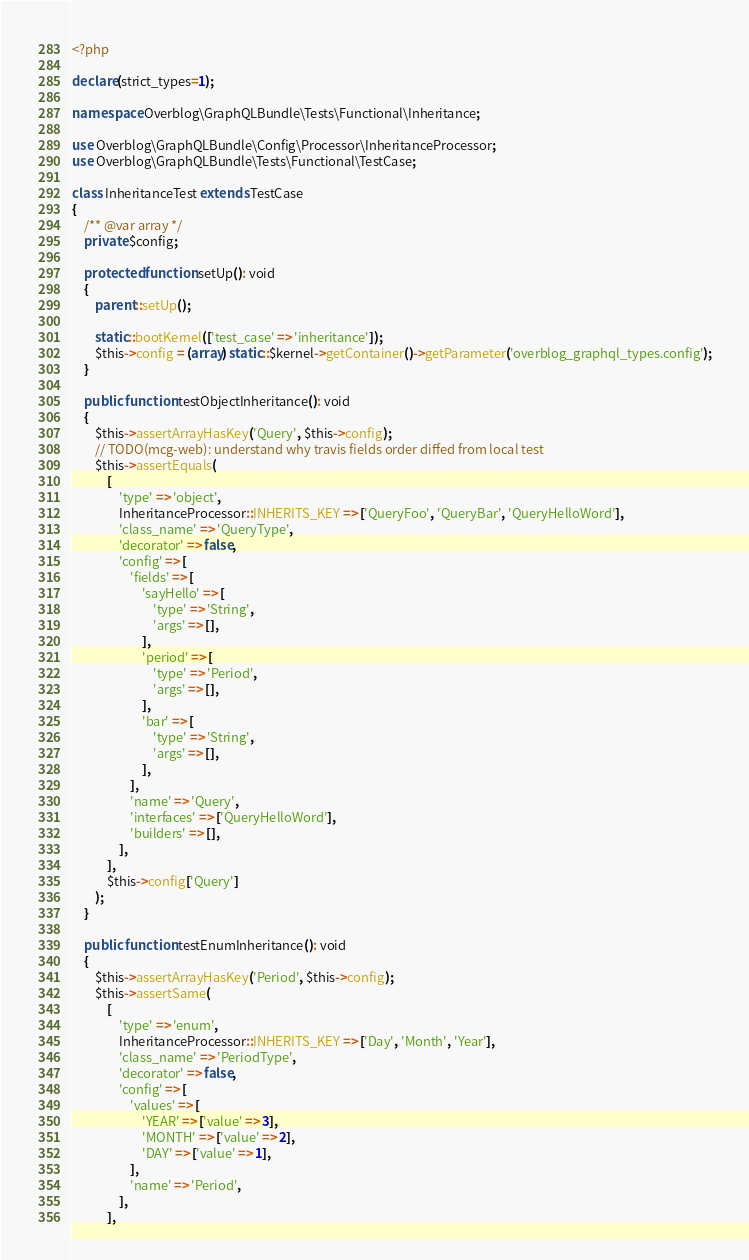Convert code to text. <code><loc_0><loc_0><loc_500><loc_500><_PHP_><?php

declare(strict_types=1);

namespace Overblog\GraphQLBundle\Tests\Functional\Inheritance;

use Overblog\GraphQLBundle\Config\Processor\InheritanceProcessor;
use Overblog\GraphQLBundle\Tests\Functional\TestCase;

class InheritanceTest extends TestCase
{
    /** @var array */
    private $config;

    protected function setUp(): void
    {
        parent::setUp();

        static::bootKernel(['test_case' => 'inheritance']);
        $this->config = (array) static::$kernel->getContainer()->getParameter('overblog_graphql_types.config');
    }

    public function testObjectInheritance(): void
    {
        $this->assertArrayHasKey('Query', $this->config);
        // TODO(mcg-web): understand why travis fields order diffed from local test
        $this->assertEquals(
            [
                'type' => 'object',
                InheritanceProcessor::INHERITS_KEY => ['QueryFoo', 'QueryBar', 'QueryHelloWord'],
                'class_name' => 'QueryType',
                'decorator' => false,
                'config' => [
                    'fields' => [
                        'sayHello' => [
                            'type' => 'String',
                            'args' => [],
                        ],
                        'period' => [
                            'type' => 'Period',
                            'args' => [],
                        ],
                        'bar' => [
                            'type' => 'String',
                            'args' => [],
                        ],
                    ],
                    'name' => 'Query',
                    'interfaces' => ['QueryHelloWord'],
                    'builders' => [],
                ],
            ],
            $this->config['Query']
        );
    }

    public function testEnumInheritance(): void
    {
        $this->assertArrayHasKey('Period', $this->config);
        $this->assertSame(
            [
                'type' => 'enum',
                InheritanceProcessor::INHERITS_KEY => ['Day', 'Month', 'Year'],
                'class_name' => 'PeriodType',
                'decorator' => false,
                'config' => [
                    'values' => [
                        'YEAR' => ['value' => 3],
                        'MONTH' => ['value' => 2],
                        'DAY' => ['value' => 1],
                    ],
                    'name' => 'Period',
                ],
            ],</code> 